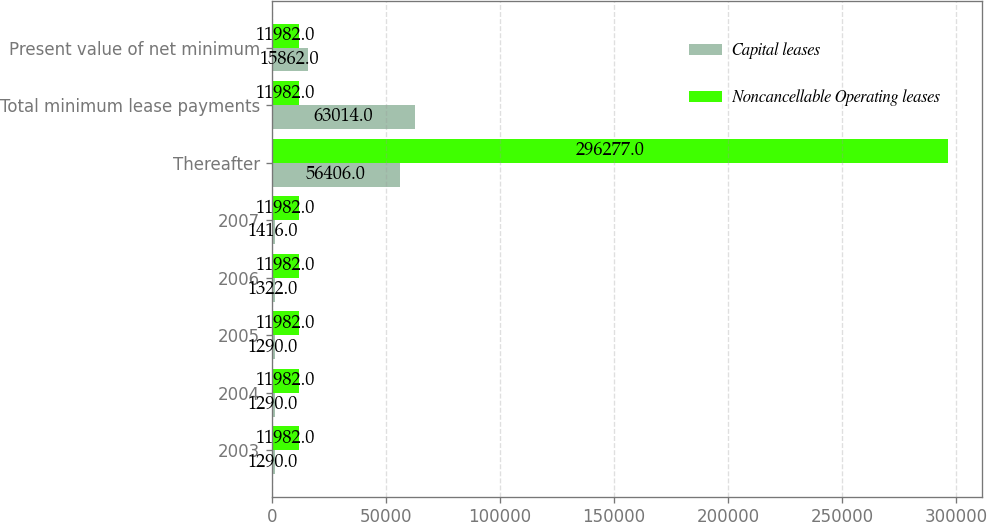Convert chart to OTSL. <chart><loc_0><loc_0><loc_500><loc_500><stacked_bar_chart><ecel><fcel>2003<fcel>2004<fcel>2005<fcel>2006<fcel>2007<fcel>Thereafter<fcel>Total minimum lease payments<fcel>Present value of net minimum<nl><fcel>Capital leases<fcel>1290<fcel>1290<fcel>1290<fcel>1322<fcel>1416<fcel>56406<fcel>63014<fcel>15862<nl><fcel>Noncancellable Operating leases<fcel>11982<fcel>11982<fcel>11982<fcel>11982<fcel>11982<fcel>296277<fcel>11982<fcel>11982<nl></chart> 